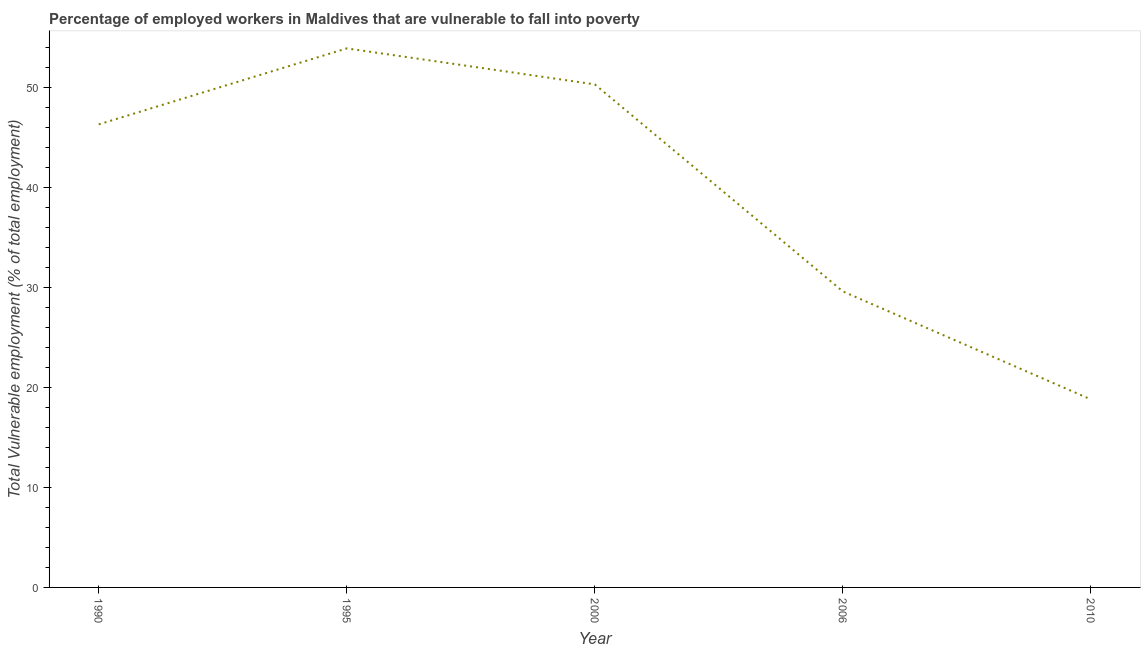What is the total vulnerable employment in 2000?
Your response must be concise. 50.3. Across all years, what is the maximum total vulnerable employment?
Make the answer very short. 53.9. Across all years, what is the minimum total vulnerable employment?
Make the answer very short. 18.8. In which year was the total vulnerable employment maximum?
Provide a succinct answer. 1995. What is the sum of the total vulnerable employment?
Give a very brief answer. 198.9. What is the difference between the total vulnerable employment in 1995 and 2000?
Your answer should be compact. 3.6. What is the average total vulnerable employment per year?
Provide a succinct answer. 39.78. What is the median total vulnerable employment?
Provide a short and direct response. 46.3. Do a majority of the years between 1990 and 1995 (inclusive) have total vulnerable employment greater than 40 %?
Offer a very short reply. Yes. What is the ratio of the total vulnerable employment in 1990 to that in 2000?
Your response must be concise. 0.92. Is the difference between the total vulnerable employment in 1995 and 2010 greater than the difference between any two years?
Give a very brief answer. Yes. What is the difference between the highest and the second highest total vulnerable employment?
Offer a terse response. 3.6. What is the difference between the highest and the lowest total vulnerable employment?
Provide a succinct answer. 35.1. In how many years, is the total vulnerable employment greater than the average total vulnerable employment taken over all years?
Make the answer very short. 3. How many lines are there?
Make the answer very short. 1. What is the difference between two consecutive major ticks on the Y-axis?
Your response must be concise. 10. Are the values on the major ticks of Y-axis written in scientific E-notation?
Your answer should be very brief. No. Does the graph contain any zero values?
Your answer should be very brief. No. What is the title of the graph?
Make the answer very short. Percentage of employed workers in Maldives that are vulnerable to fall into poverty. What is the label or title of the Y-axis?
Your answer should be very brief. Total Vulnerable employment (% of total employment). What is the Total Vulnerable employment (% of total employment) of 1990?
Give a very brief answer. 46.3. What is the Total Vulnerable employment (% of total employment) in 1995?
Provide a succinct answer. 53.9. What is the Total Vulnerable employment (% of total employment) of 2000?
Provide a succinct answer. 50.3. What is the Total Vulnerable employment (% of total employment) in 2006?
Keep it short and to the point. 29.6. What is the Total Vulnerable employment (% of total employment) of 2010?
Give a very brief answer. 18.8. What is the difference between the Total Vulnerable employment (% of total employment) in 1990 and 1995?
Give a very brief answer. -7.6. What is the difference between the Total Vulnerable employment (% of total employment) in 1990 and 2006?
Provide a succinct answer. 16.7. What is the difference between the Total Vulnerable employment (% of total employment) in 1990 and 2010?
Your answer should be compact. 27.5. What is the difference between the Total Vulnerable employment (% of total employment) in 1995 and 2006?
Provide a short and direct response. 24.3. What is the difference between the Total Vulnerable employment (% of total employment) in 1995 and 2010?
Offer a very short reply. 35.1. What is the difference between the Total Vulnerable employment (% of total employment) in 2000 and 2006?
Provide a succinct answer. 20.7. What is the difference between the Total Vulnerable employment (% of total employment) in 2000 and 2010?
Give a very brief answer. 31.5. What is the difference between the Total Vulnerable employment (% of total employment) in 2006 and 2010?
Your answer should be very brief. 10.8. What is the ratio of the Total Vulnerable employment (% of total employment) in 1990 to that in 1995?
Make the answer very short. 0.86. What is the ratio of the Total Vulnerable employment (% of total employment) in 1990 to that in 2006?
Keep it short and to the point. 1.56. What is the ratio of the Total Vulnerable employment (% of total employment) in 1990 to that in 2010?
Keep it short and to the point. 2.46. What is the ratio of the Total Vulnerable employment (% of total employment) in 1995 to that in 2000?
Offer a terse response. 1.07. What is the ratio of the Total Vulnerable employment (% of total employment) in 1995 to that in 2006?
Keep it short and to the point. 1.82. What is the ratio of the Total Vulnerable employment (% of total employment) in 1995 to that in 2010?
Make the answer very short. 2.87. What is the ratio of the Total Vulnerable employment (% of total employment) in 2000 to that in 2006?
Provide a succinct answer. 1.7. What is the ratio of the Total Vulnerable employment (% of total employment) in 2000 to that in 2010?
Provide a succinct answer. 2.68. What is the ratio of the Total Vulnerable employment (% of total employment) in 2006 to that in 2010?
Offer a very short reply. 1.57. 